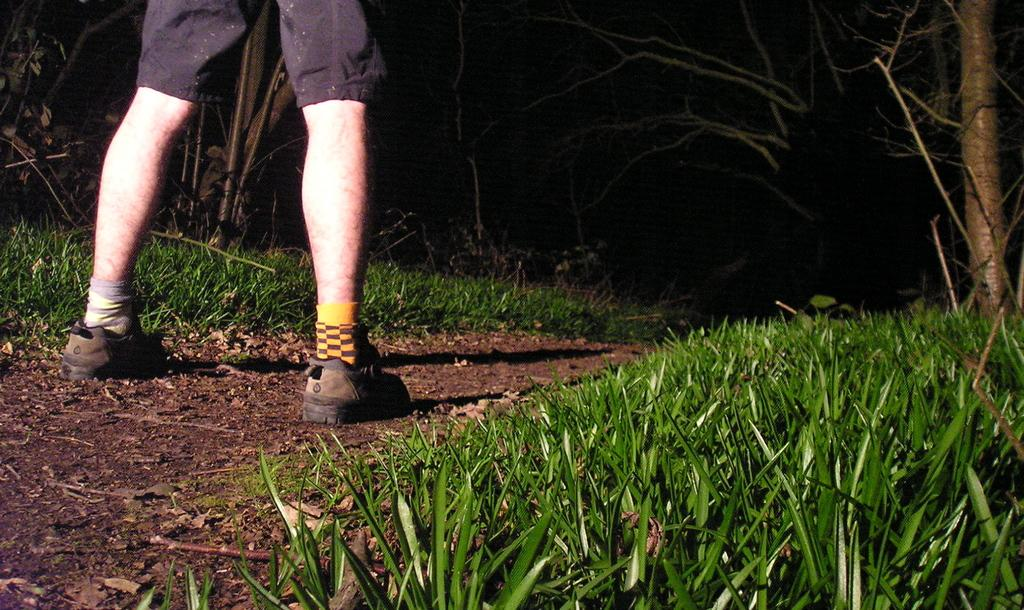What part of a person can be seen in the image? There are legs of a person visible in the image. What type of footwear is the person wearing? The person is wearing shoes. What type of terrain is visible in the image? There is grass visible in the image. What type of vegetation is visible in the image? There are trees visible in the image. What type of riddle is the person solving in the image? There is no riddle present in the image; it only shows a person's legs and the surrounding environment. 